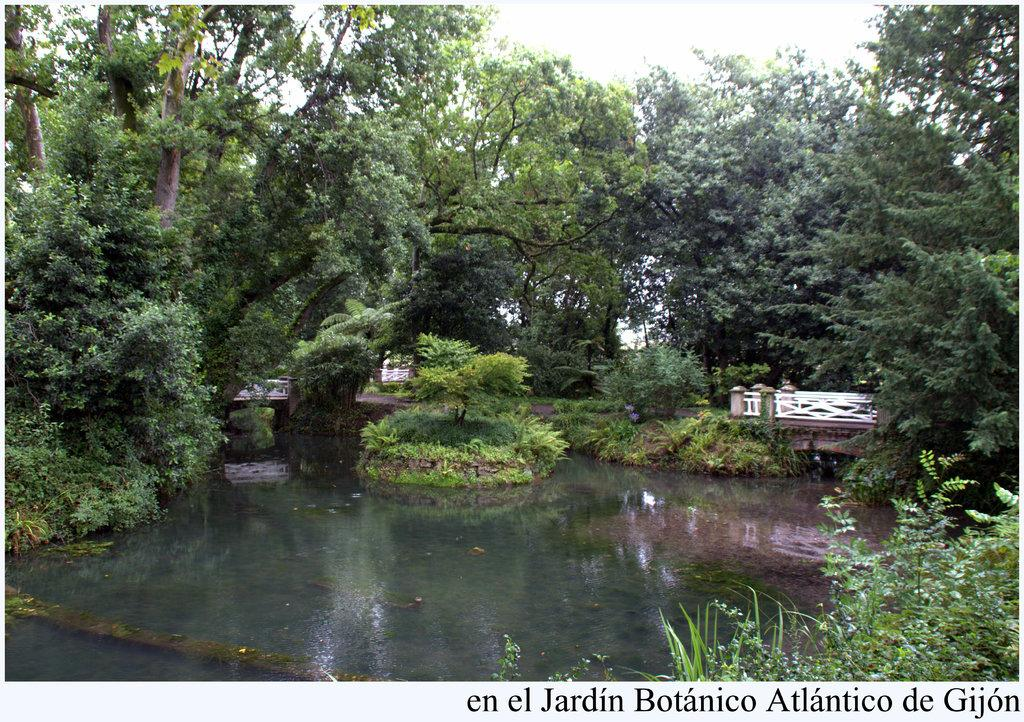What type of vegetation can be seen in the image? There are trees, plants, and grass visible in the image. Are there any structures in the image? Yes, there are bridges in the image. What natural element is visible in the image? Water is visible in the image. What part of the sky can be seen in the image? The sky is visible in the image. Is there any text present in the image? Yes, there is text at the bottom of the image. What type of loaf is being used as a vase for flowers in the image? There is no loaf or vase present in the image; it features trees, plants, grass, bridges, water, sky, and text. 